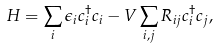<formula> <loc_0><loc_0><loc_500><loc_500>H = \sum _ { i } \epsilon _ { i } c _ { i } ^ { \dagger } c _ { i } - V \sum _ { i , j } R _ { i j } c _ { i } ^ { \dagger } c _ { j } ,</formula> 